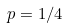<formula> <loc_0><loc_0><loc_500><loc_500>p = 1 / 4</formula> 